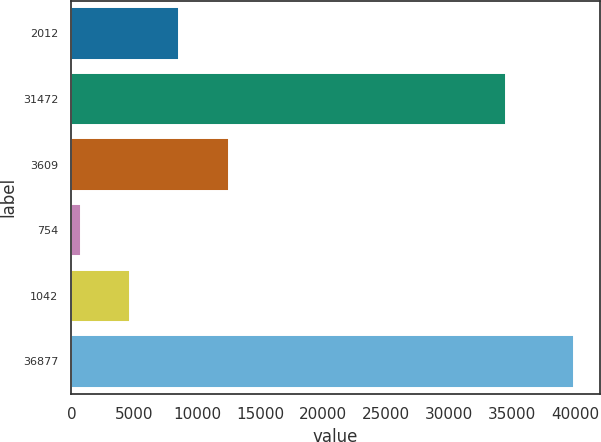Convert chart. <chart><loc_0><loc_0><loc_500><loc_500><bar_chart><fcel>2012<fcel>31472<fcel>3609<fcel>754<fcel>1042<fcel>36877<nl><fcel>8584.2<fcel>34505<fcel>12505.3<fcel>742<fcel>4663.1<fcel>39953<nl></chart> 